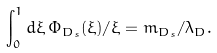<formula> <loc_0><loc_0><loc_500><loc_500>\int _ { 0 } ^ { 1 } d \xi \, \Phi _ { D _ { s } } ( \xi ) / \xi = m _ { D _ { s } } / \lambda _ { D } .</formula> 